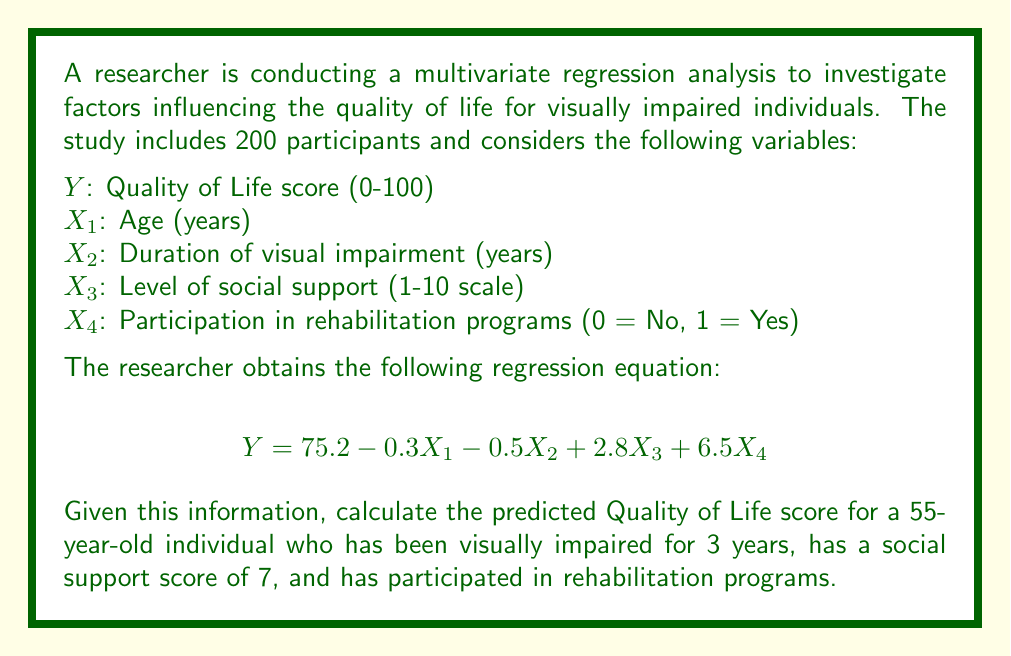What is the answer to this math problem? To solve this problem, we need to use the given multivariate regression equation and substitute the values for each variable. Let's break it down step by step:

1. Regression equation:
   $$Y = 75.2 - 0.3X_1 - 0.5X_2 + 2.8X_3 + 6.5X_4$$

2. Given values:
   $X_1$ (Age) = 55 years
   $X_2$ (Duration of visual impairment) = 3 years
   $X_3$ (Level of social support) = 7
   $X_4$ (Participation in rehabilitation programs) = 1 (Yes)

3. Substitute these values into the equation:
   $$Y = 75.2 - 0.3(55) - 0.5(3) + 2.8(7) + 6.5(1)$$

4. Calculate each term:
   $$Y = 75.2 - 16.5 - 1.5 + 19.6 + 6.5$$

5. Sum up all terms:
   $$Y = 83.3$$

Therefore, the predicted Quality of Life score for the given individual is 83.3 out of 100.
Answer: 83.3 